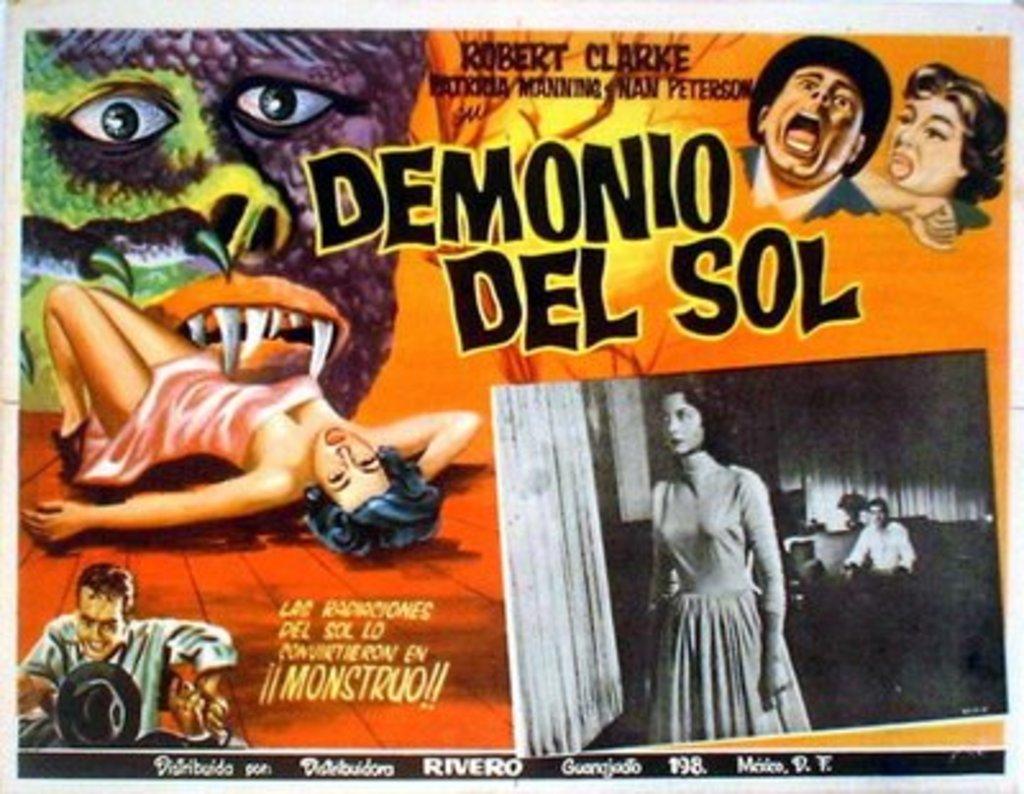What is the ad promoting?
Offer a terse response. Demonio del sol. What is the name in bold at the bottom?
Offer a terse response. Rivero. 